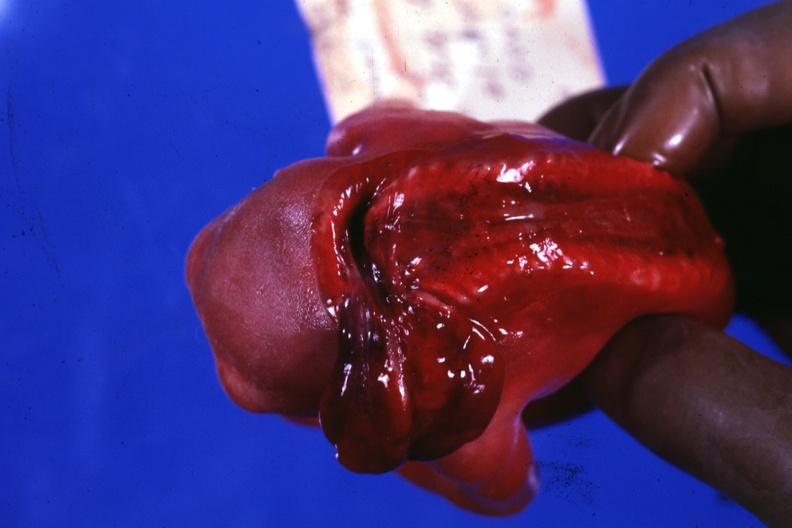does leiomyosarcoma show posterior view to show open cord?
Answer the question using a single word or phrase. No 